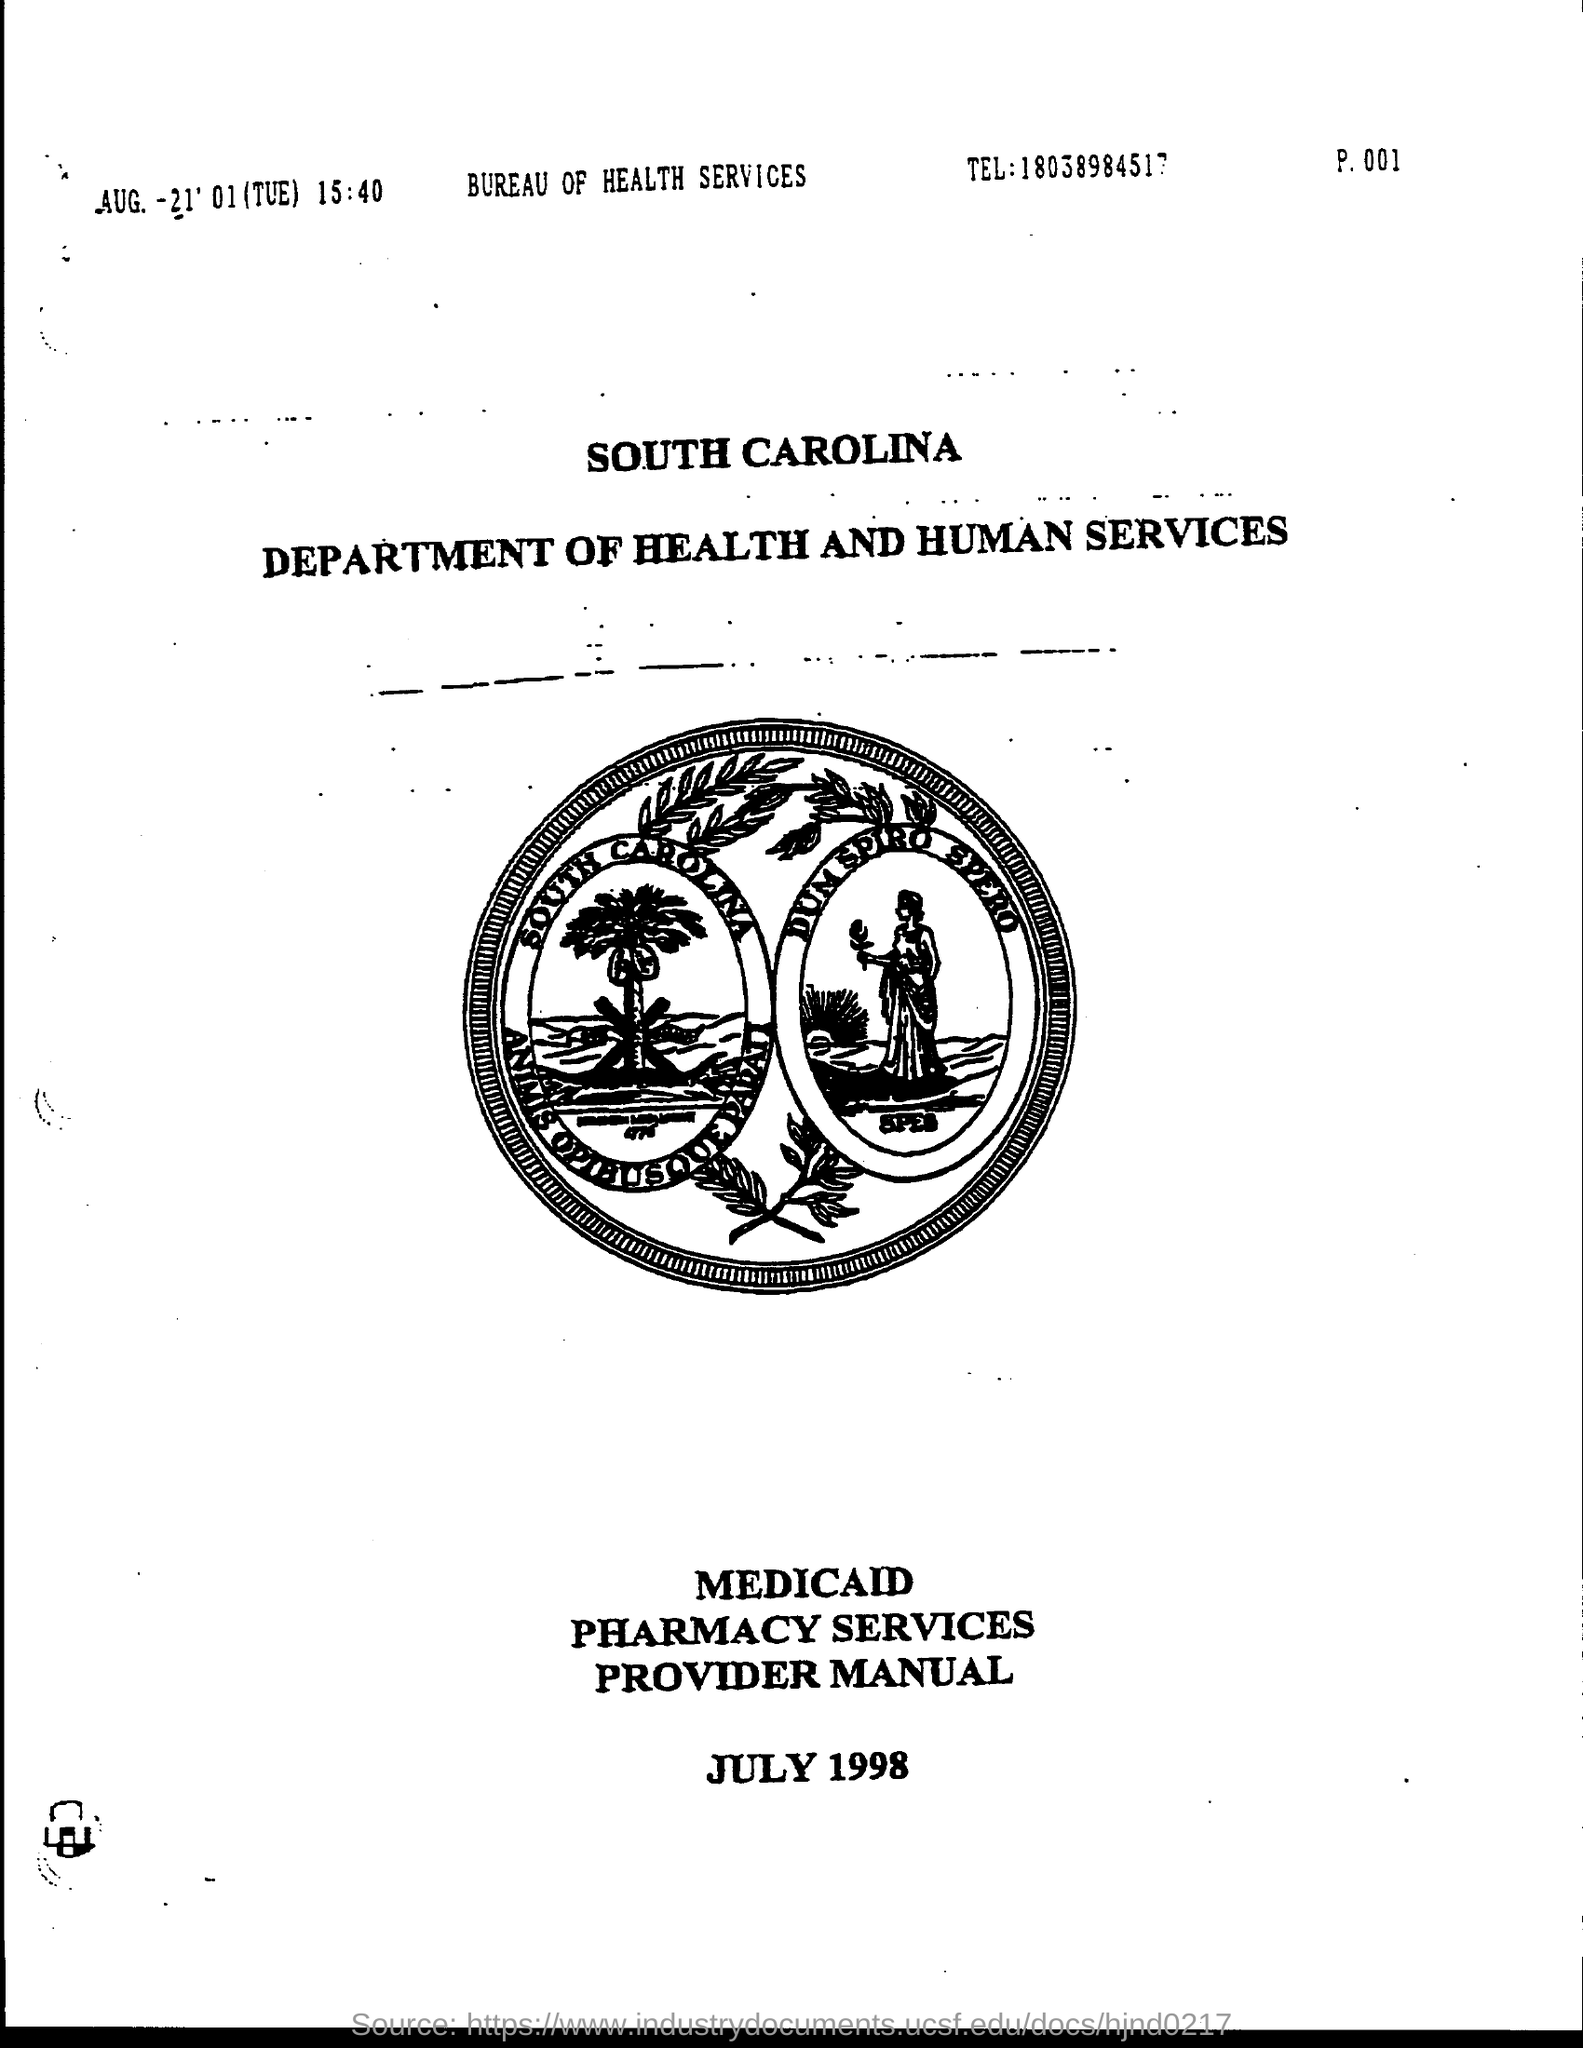Specify some key components in this picture. The telephone number for the Bureau of Health Services is 18038984517. 